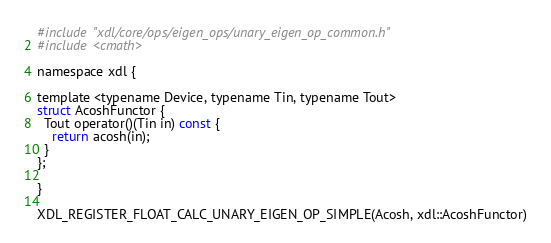<code> <loc_0><loc_0><loc_500><loc_500><_Cuda_>#include "xdl/core/ops/eigen_ops/unary_eigen_op_common.h"
#include <cmath>

namespace xdl {

template <typename Device, typename Tin, typename Tout>
struct AcoshFunctor {
  Tout operator()(Tin in) const {
    return acosh(in);
  }
};

}

XDL_REGISTER_FLOAT_CALC_UNARY_EIGEN_OP_SIMPLE(Acosh, xdl::AcoshFunctor)
</code> 